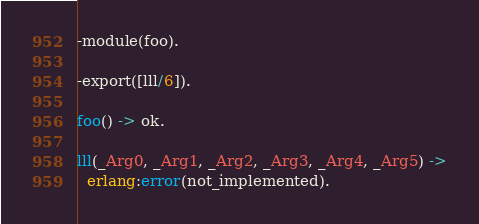Convert code to text. <code><loc_0><loc_0><loc_500><loc_500><_Erlang_>-module(foo).

-export([lll/6]).

foo() -> ok.

lll(_Arg0, _Arg1, _Arg2, _Arg3, _Arg4, _Arg5) ->
  erlang:error(not_implemented).</code> 